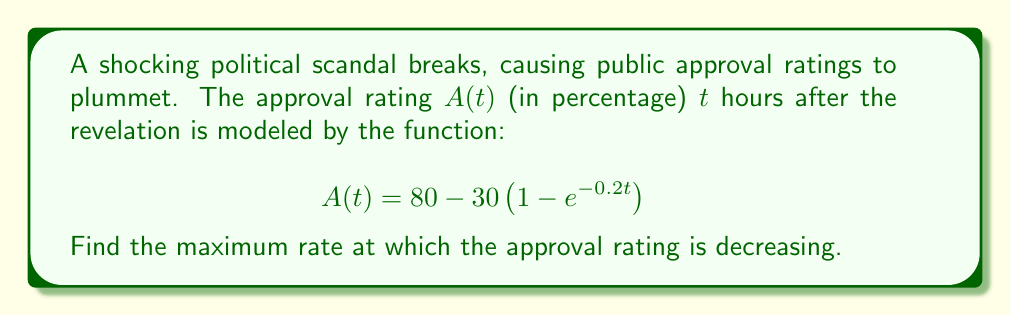Teach me how to tackle this problem. To find the maximum rate of decrease, we need to:
1. Find the derivative of $A(t)$
2. Find the minimum value of this derivative (as we're looking for the maximum rate of decrease)

Step 1: Find the derivative
$$\frac{dA}{dt} = -30 \cdot (-0.2e^{-0.2t}) = 6e^{-0.2t}$$

Step 2: Find the minimum value of the derivative
The derivative is an exponential function that starts at 6 when $t=0$ and approaches 0 as $t$ approaches infinity. Therefore, the minimum value occurs at $t=0$.

$$\min\left(\frac{dA}{dt}\right) = 6e^{-0.2 \cdot 0} = 6$$

Since we're looking for the rate of decrease, we need the negative of this value.

Maximum rate of decrease = $-6$ percentage points per hour
Answer: $-6$ percentage points/hour 